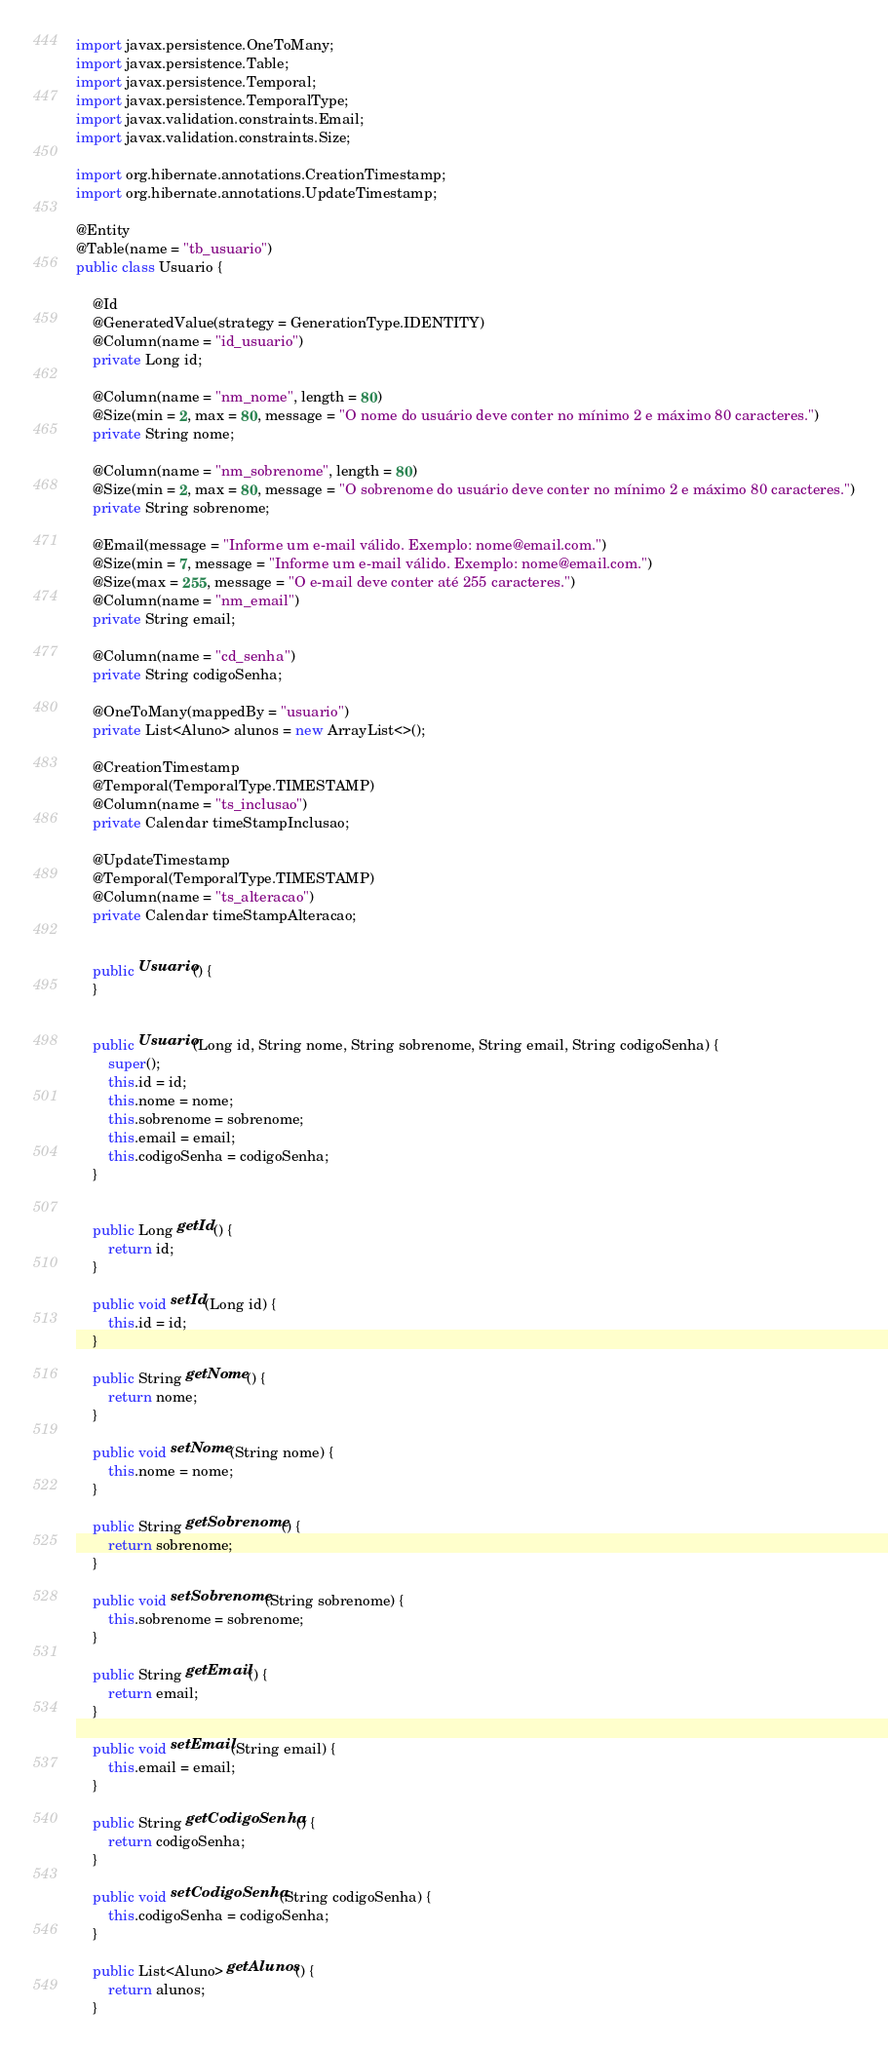<code> <loc_0><loc_0><loc_500><loc_500><_Java_>import javax.persistence.OneToMany;
import javax.persistence.Table;
import javax.persistence.Temporal;
import javax.persistence.TemporalType;
import javax.validation.constraints.Email;
import javax.validation.constraints.Size;

import org.hibernate.annotations.CreationTimestamp;
import org.hibernate.annotations.UpdateTimestamp;

@Entity
@Table(name = "tb_usuario")
public class Usuario {
	
	@Id
	@GeneratedValue(strategy = GenerationType.IDENTITY)
	@Column(name = "id_usuario")
	private Long id;
	
	@Column(name = "nm_nome", length = 80)
	@Size(min = 2, max = 80, message = "O nome do usuário deve conter no mínimo 2 e máximo 80 caracteres.")
	private String nome;

	@Column(name = "nm_sobrenome", length = 80)
	@Size(min = 2, max = 80, message = "O sobrenome do usuário deve conter no mínimo 2 e máximo 80 caracteres.")
	private String sobrenome;

	@Email(message = "Informe um e-mail válido. Exemplo: nome@email.com.")
	@Size(min = 7, message = "Informe um e-mail válido. Exemplo: nome@email.com.")
	@Size(max = 255, message = "O e-mail deve conter até 255 caracteres.")
	@Column(name = "nm_email")
	private String email;

	@Column(name = "cd_senha")
	private String codigoSenha;
	
	@OneToMany(mappedBy = "usuario")
	private List<Aluno> alunos = new ArrayList<>();
	
	@CreationTimestamp
	@Temporal(TemporalType.TIMESTAMP)
	@Column(name = "ts_inclusao")
	private Calendar timeStampInclusao;

	@UpdateTimestamp
	@Temporal(TemporalType.TIMESTAMP)
	@Column(name = "ts_alteracao")
	private Calendar timeStampAlteracao;

	
	public Usuario() {
	}


	public Usuario(Long id, String nome, String sobrenome, String email, String codigoSenha) {
		super();
		this.id = id;
		this.nome = nome;
		this.sobrenome = sobrenome;
		this.email = email;
		this.codigoSenha = codigoSenha;
	}


	public Long getId() {
		return id;
	}

	public void setId(Long id) {
		this.id = id;
	}

	public String getNome() {
		return nome;
	}

	public void setNome(String nome) {
		this.nome = nome;
	}

	public String getSobrenome() {
		return sobrenome;
	}

	public void setSobrenome(String sobrenome) {
		this.sobrenome = sobrenome;
	}

	public String getEmail() {
		return email;
	}

	public void setEmail(String email) {
		this.email = email;
	}

	public String getCodigoSenha() {
		return codigoSenha;
	}

	public void setCodigoSenha(String codigoSenha) {
		this.codigoSenha = codigoSenha;
	}
	
	public List<Aluno> getAlunos() {
		return alunos;
	}
</code> 